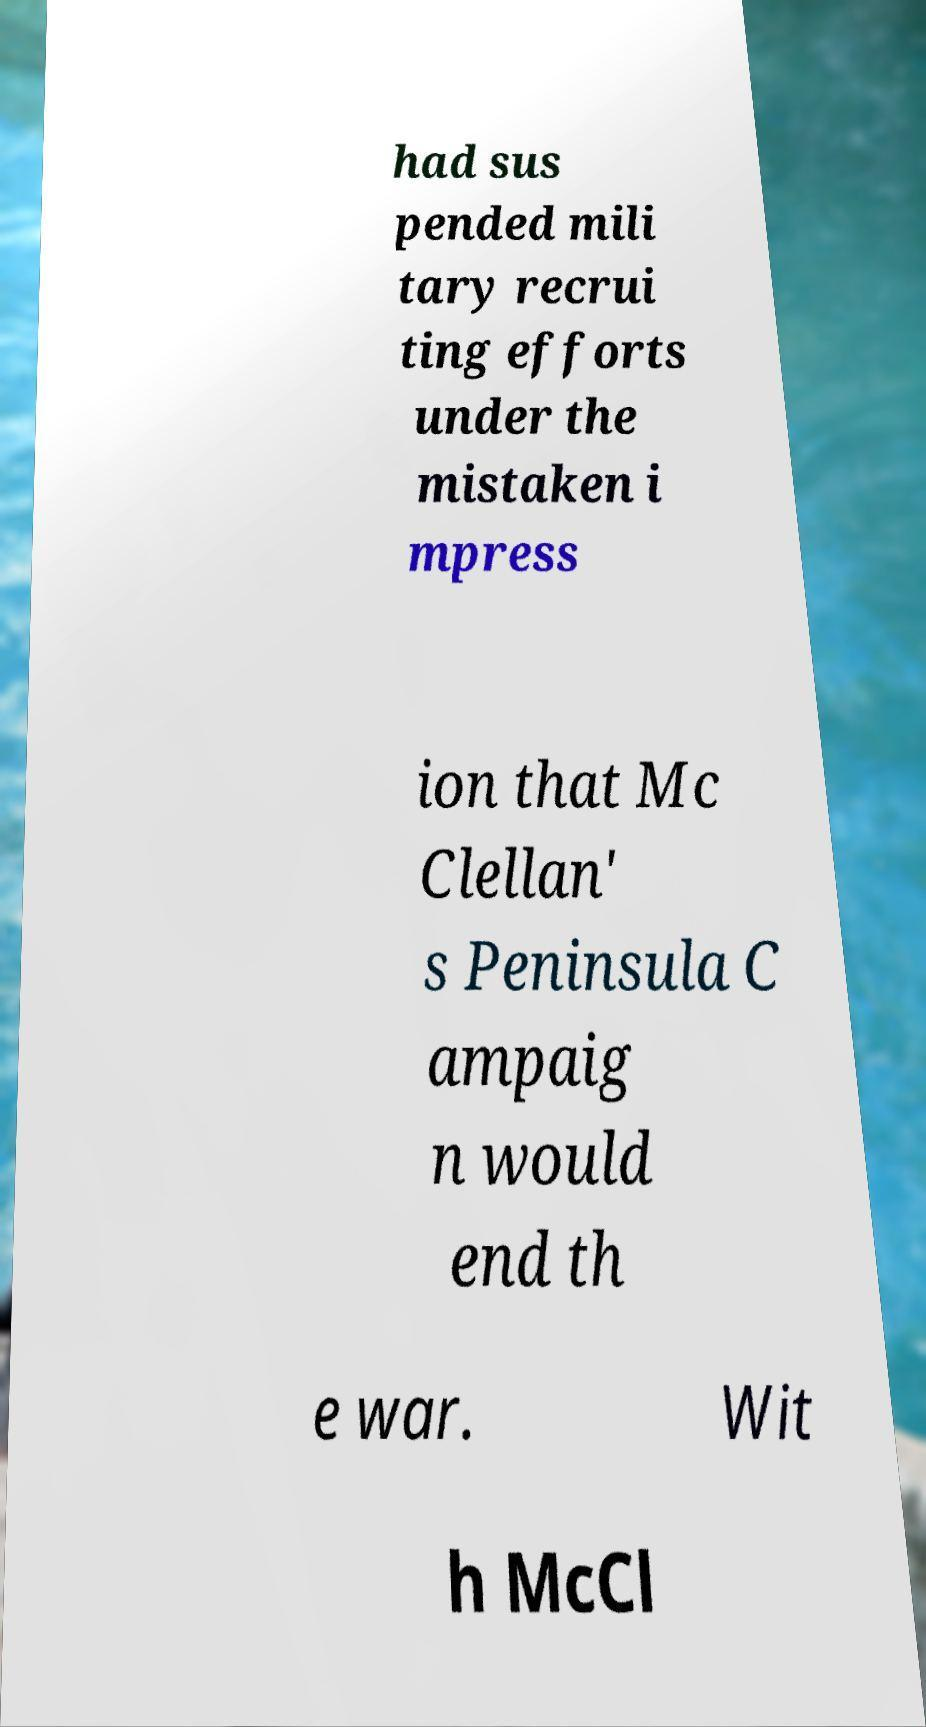For documentation purposes, I need the text within this image transcribed. Could you provide that? had sus pended mili tary recrui ting efforts under the mistaken i mpress ion that Mc Clellan' s Peninsula C ampaig n would end th e war. Wit h McCl 